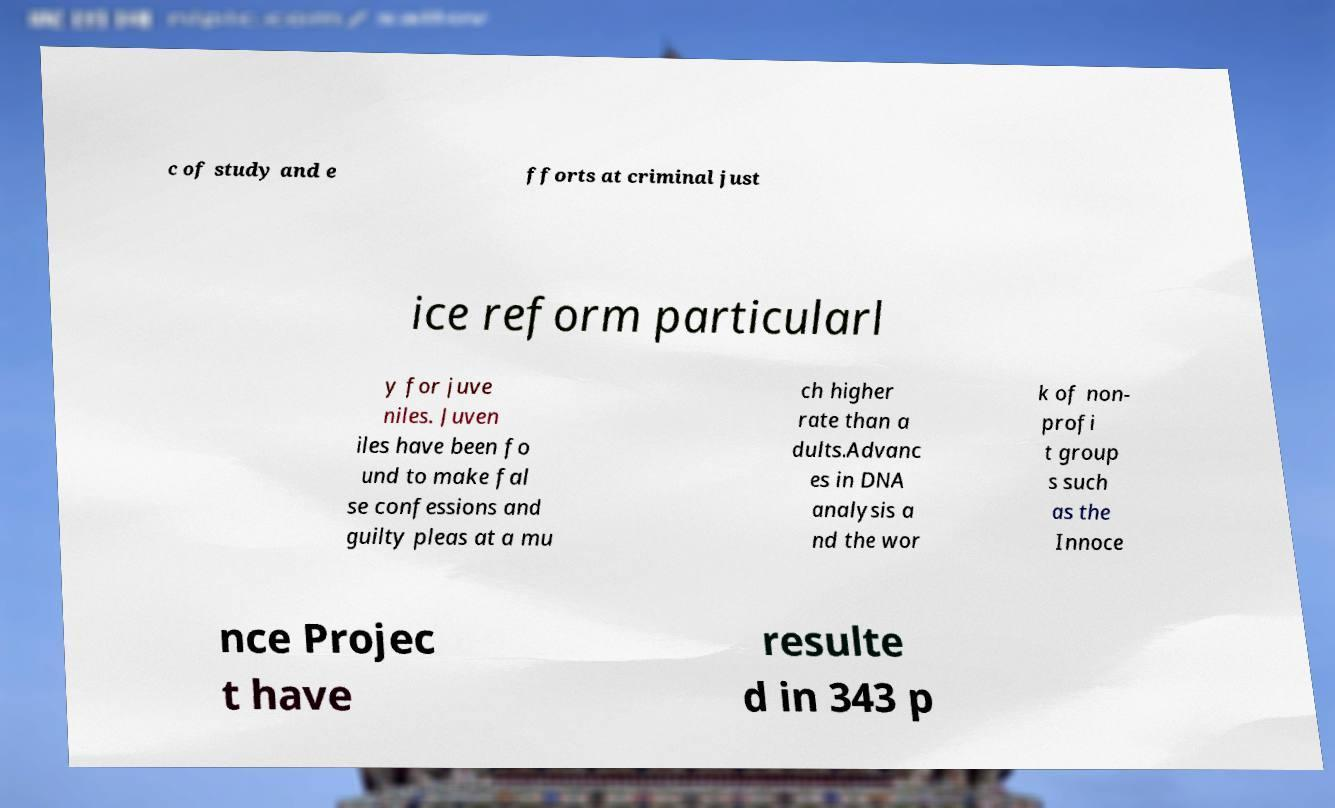I need the written content from this picture converted into text. Can you do that? c of study and e fforts at criminal just ice reform particularl y for juve niles. Juven iles have been fo und to make fal se confessions and guilty pleas at a mu ch higher rate than a dults.Advanc es in DNA analysis a nd the wor k of non- profi t group s such as the Innoce nce Projec t have resulte d in 343 p 